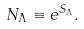<formula> <loc_0><loc_0><loc_500><loc_500>N _ { \Lambda } \equiv e ^ { S _ { \Lambda } } .</formula> 